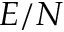Convert formula to latex. <formula><loc_0><loc_0><loc_500><loc_500>E / N</formula> 